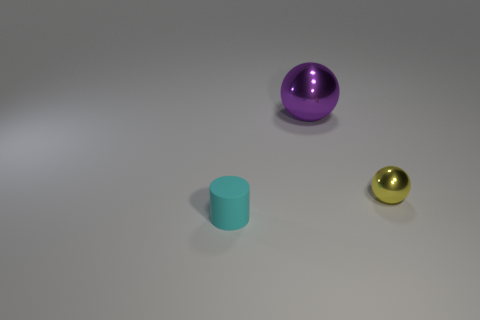Add 1 gray cylinders. How many objects exist? 4 Subtract all purple balls. How many balls are left? 1 Subtract all spheres. How many objects are left? 1 Subtract 1 balls. How many balls are left? 1 Subtract all brown balls. Subtract all cyan blocks. How many balls are left? 2 Subtract all yellow cylinders. How many yellow spheres are left? 1 Subtract all tiny rubber cylinders. Subtract all big purple rubber balls. How many objects are left? 2 Add 3 tiny yellow spheres. How many tiny yellow spheres are left? 4 Add 1 tiny yellow things. How many tiny yellow things exist? 2 Subtract 1 purple balls. How many objects are left? 2 